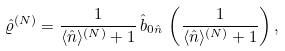<formula> <loc_0><loc_0><loc_500><loc_500>\hat { \varrho } ^ { ( N ) } = \frac { 1 } { \langle \hat { n } \rangle ^ { ( N ) } + 1 } \, \hat { b } _ { 0 \hat { n } } \, \left ( \frac { 1 } { \langle \hat { n } \rangle ^ { ( N ) } + 1 } \right ) ,</formula> 